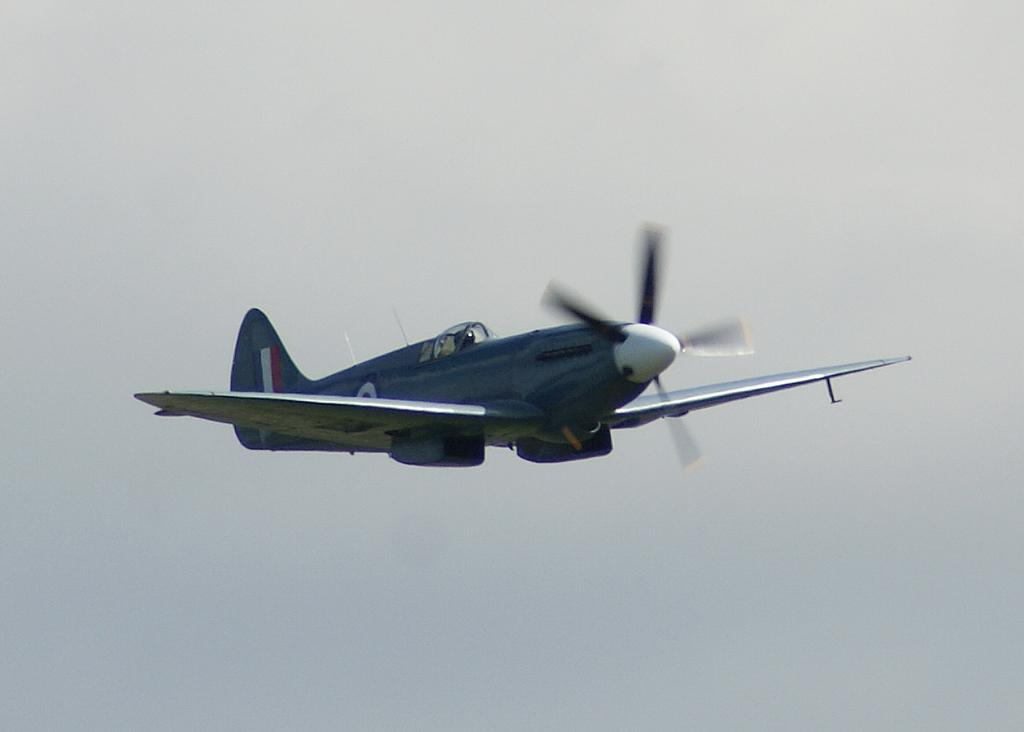What is the main subject of the image? There is an aircraft in the center of the image. What type of dress is the aircraft wearing in the image? Aircrafts do not wear dresses, as they are inanimate objects and not capable of wearing clothing. 